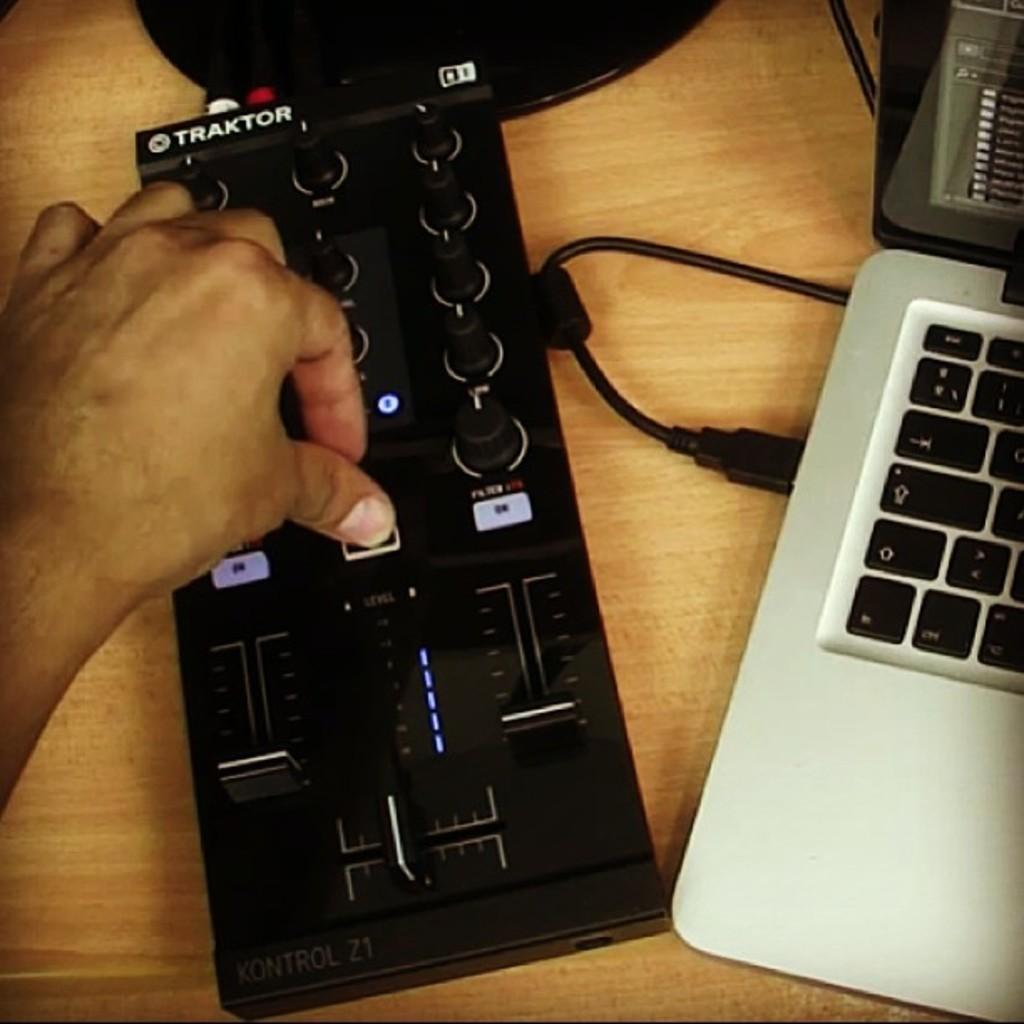<image>
Provide a brief description of the given image. A black Traktor controller next to a laptop computer 